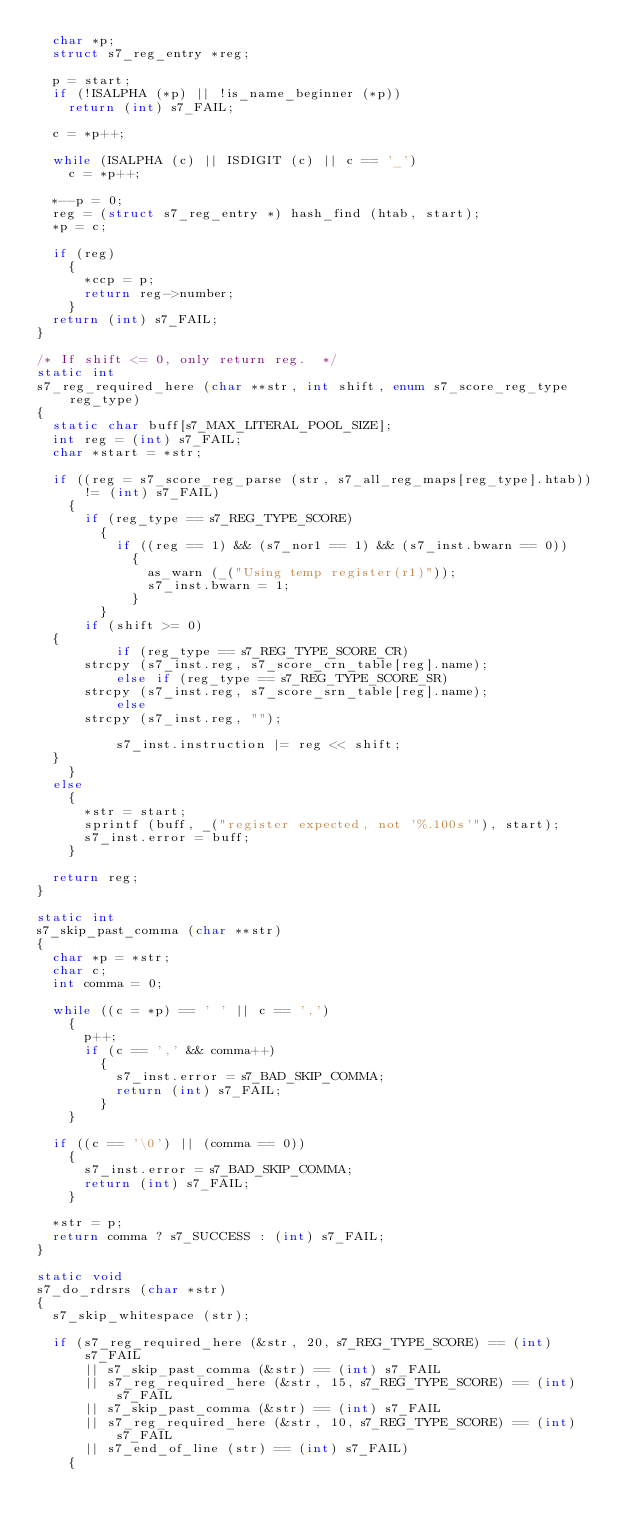<code> <loc_0><loc_0><loc_500><loc_500><_C_>  char *p;
  struct s7_reg_entry *reg;

  p = start;
  if (!ISALPHA (*p) || !is_name_beginner (*p))
    return (int) s7_FAIL;

  c = *p++;

  while (ISALPHA (c) || ISDIGIT (c) || c == '_')
    c = *p++;

  *--p = 0;
  reg = (struct s7_reg_entry *) hash_find (htab, start);
  *p = c;

  if (reg)
    {
      *ccp = p;
      return reg->number;
    }
  return (int) s7_FAIL;
}

/* If shift <= 0, only return reg.  */
static int
s7_reg_required_here (char **str, int shift, enum s7_score_reg_type reg_type)
{
  static char buff[s7_MAX_LITERAL_POOL_SIZE];
  int reg = (int) s7_FAIL;
  char *start = *str;

  if ((reg = s7_score_reg_parse (str, s7_all_reg_maps[reg_type].htab)) != (int) s7_FAIL)
    {
      if (reg_type == s7_REG_TYPE_SCORE)
        {
          if ((reg == 1) && (s7_nor1 == 1) && (s7_inst.bwarn == 0))
            {
              as_warn (_("Using temp register(r1)"));
              s7_inst.bwarn = 1;
            }
        }
      if (shift >= 0)
	{
          if (reg_type == s7_REG_TYPE_SCORE_CR)
	    strcpy (s7_inst.reg, s7_score_crn_table[reg].name);
          else if (reg_type == s7_REG_TYPE_SCORE_SR)
	    strcpy (s7_inst.reg, s7_score_srn_table[reg].name);
          else
	    strcpy (s7_inst.reg, "");

          s7_inst.instruction |= reg << shift;
	}
    }
  else
    {
      *str = start;
      sprintf (buff, _("register expected, not '%.100s'"), start);
      s7_inst.error = buff;
    }

  return reg;
}

static int
s7_skip_past_comma (char **str)
{
  char *p = *str;
  char c;
  int comma = 0;

  while ((c = *p) == ' ' || c == ',')
    {
      p++;
      if (c == ',' && comma++)
        {
          s7_inst.error = s7_BAD_SKIP_COMMA;
          return (int) s7_FAIL;
        }
    }

  if ((c == '\0') || (comma == 0))
    {
      s7_inst.error = s7_BAD_SKIP_COMMA;
      return (int) s7_FAIL;
    }

  *str = p;
  return comma ? s7_SUCCESS : (int) s7_FAIL;
}

static void
s7_do_rdrsrs (char *str)
{
  s7_skip_whitespace (str);

  if (s7_reg_required_here (&str, 20, s7_REG_TYPE_SCORE) == (int) s7_FAIL
      || s7_skip_past_comma (&str) == (int) s7_FAIL
      || s7_reg_required_here (&str, 15, s7_REG_TYPE_SCORE) == (int) s7_FAIL
      || s7_skip_past_comma (&str) == (int) s7_FAIL
      || s7_reg_required_here (&str, 10, s7_REG_TYPE_SCORE) == (int) s7_FAIL
      || s7_end_of_line (str) == (int) s7_FAIL)
    {</code> 